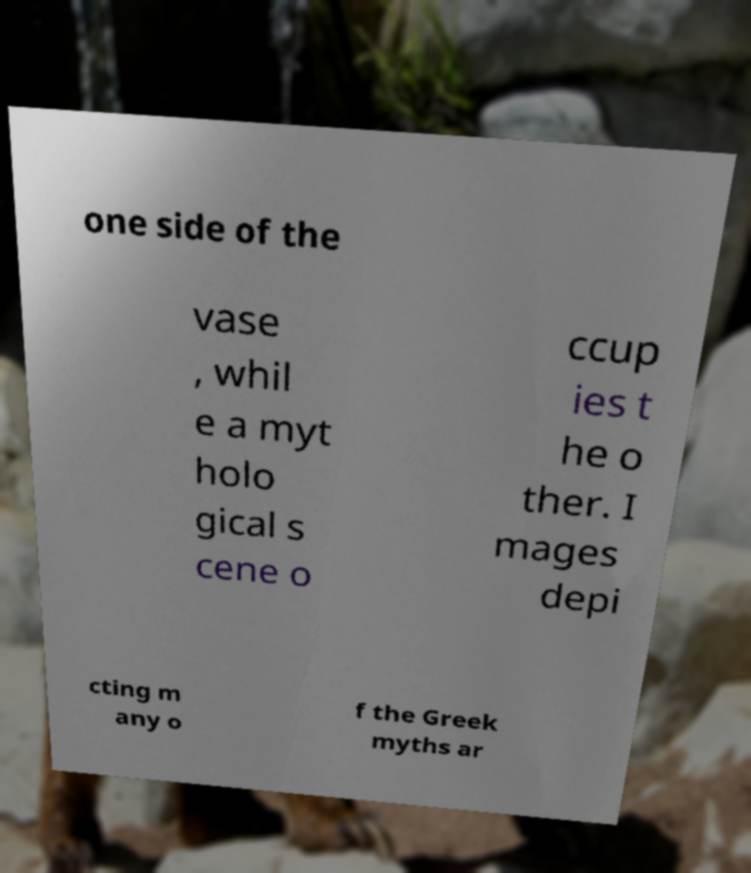Can you read and provide the text displayed in the image?This photo seems to have some interesting text. Can you extract and type it out for me? one side of the vase , whil e a myt holo gical s cene o ccup ies t he o ther. I mages depi cting m any o f the Greek myths ar 